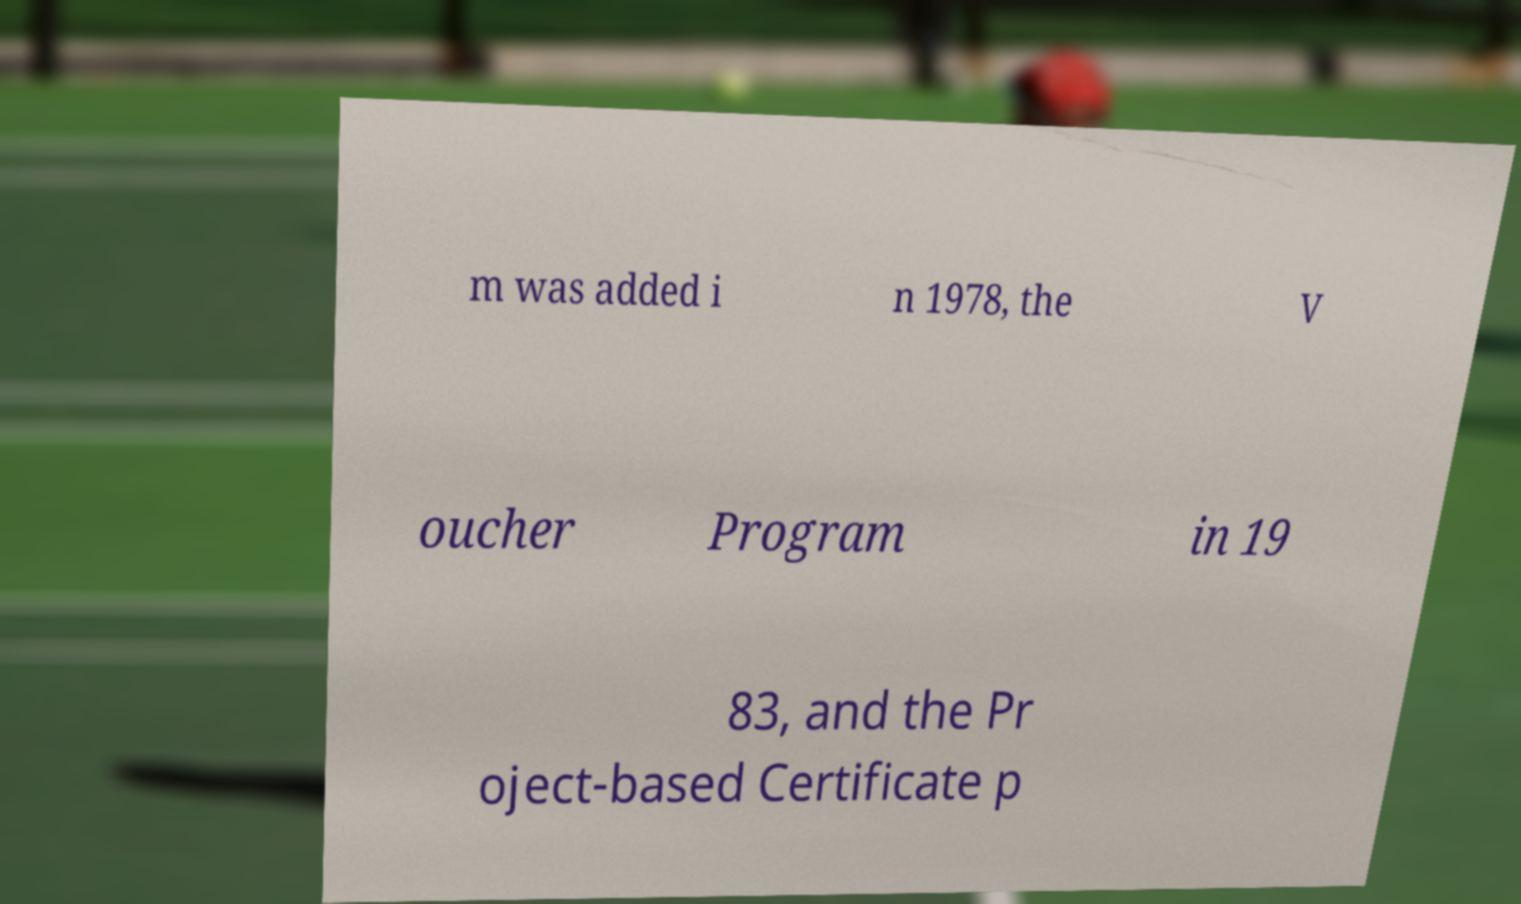Could you extract and type out the text from this image? m was added i n 1978, the V oucher Program in 19 83, and the Pr oject-based Certificate p 